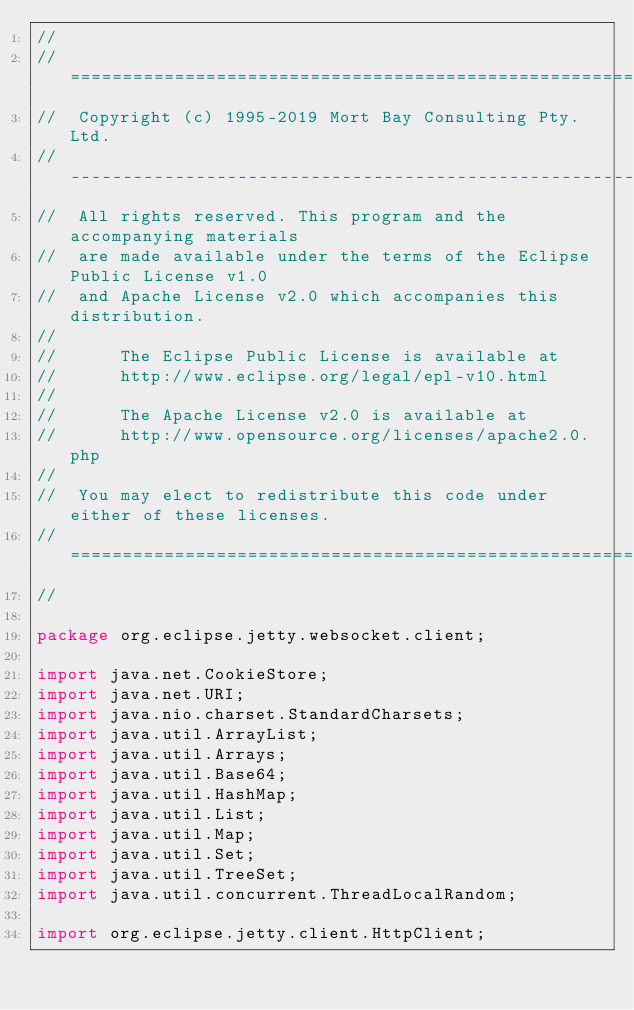<code> <loc_0><loc_0><loc_500><loc_500><_Java_>//
//  ========================================================================
//  Copyright (c) 1995-2019 Mort Bay Consulting Pty. Ltd.
//  ------------------------------------------------------------------------
//  All rights reserved. This program and the accompanying materials
//  are made available under the terms of the Eclipse Public License v1.0
//  and Apache License v2.0 which accompanies this distribution.
//
//      The Eclipse Public License is available at
//      http://www.eclipse.org/legal/epl-v10.html
//
//      The Apache License v2.0 is available at
//      http://www.opensource.org/licenses/apache2.0.php
//
//  You may elect to redistribute this code under either of these licenses.
//  ========================================================================
//

package org.eclipse.jetty.websocket.client;

import java.net.CookieStore;
import java.net.URI;
import java.nio.charset.StandardCharsets;
import java.util.ArrayList;
import java.util.Arrays;
import java.util.Base64;
import java.util.HashMap;
import java.util.List;
import java.util.Map;
import java.util.Set;
import java.util.TreeSet;
import java.util.concurrent.ThreadLocalRandom;

import org.eclipse.jetty.client.HttpClient;</code> 